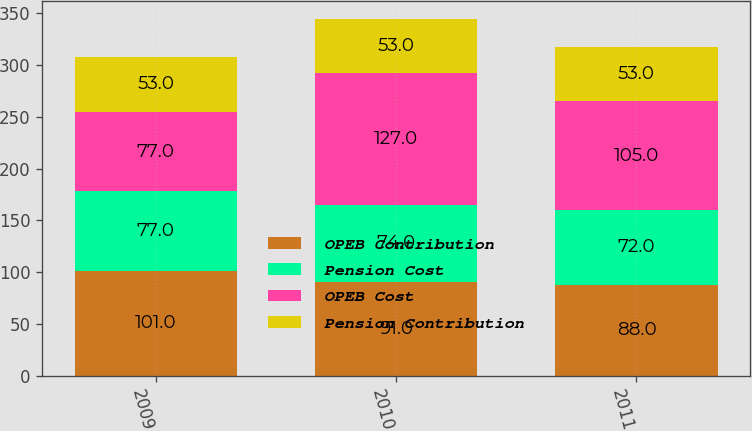Convert chart to OTSL. <chart><loc_0><loc_0><loc_500><loc_500><stacked_bar_chart><ecel><fcel>2009<fcel>2010<fcel>2011<nl><fcel>OPEB Contribution<fcel>101<fcel>91<fcel>88<nl><fcel>Pension Cost<fcel>77<fcel>74<fcel>72<nl><fcel>OPEB Cost<fcel>77<fcel>127<fcel>105<nl><fcel>Pension Contribution<fcel>53<fcel>53<fcel>53<nl></chart> 